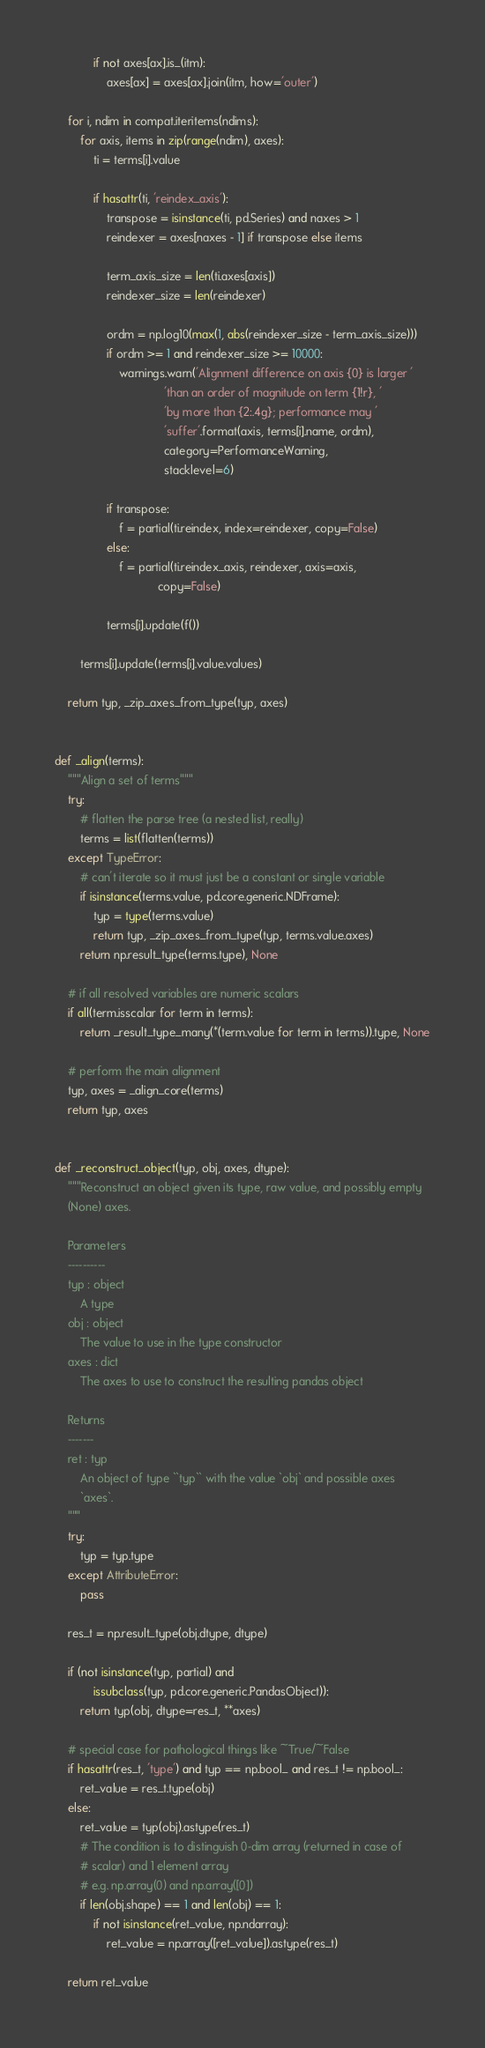<code> <loc_0><loc_0><loc_500><loc_500><_Python_>
            if not axes[ax].is_(itm):
                axes[ax] = axes[ax].join(itm, how='outer')

    for i, ndim in compat.iteritems(ndims):
        for axis, items in zip(range(ndim), axes):
            ti = terms[i].value

            if hasattr(ti, 'reindex_axis'):
                transpose = isinstance(ti, pd.Series) and naxes > 1
                reindexer = axes[naxes - 1] if transpose else items

                term_axis_size = len(ti.axes[axis])
                reindexer_size = len(reindexer)

                ordm = np.log10(max(1, abs(reindexer_size - term_axis_size)))
                if ordm >= 1 and reindexer_size >= 10000:
                    warnings.warn('Alignment difference on axis {0} is larger '
                                  'than an order of magnitude on term {1!r}, '
                                  'by more than {2:.4g}; performance may '
                                  'suffer'.format(axis, terms[i].name, ordm),
                                  category=PerformanceWarning,
                                  stacklevel=6)

                if transpose:
                    f = partial(ti.reindex, index=reindexer, copy=False)
                else:
                    f = partial(ti.reindex_axis, reindexer, axis=axis,
                                copy=False)

                terms[i].update(f())

        terms[i].update(terms[i].value.values)

    return typ, _zip_axes_from_type(typ, axes)


def _align(terms):
    """Align a set of terms"""
    try:
        # flatten the parse tree (a nested list, really)
        terms = list(flatten(terms))
    except TypeError:
        # can't iterate so it must just be a constant or single variable
        if isinstance(terms.value, pd.core.generic.NDFrame):
            typ = type(terms.value)
            return typ, _zip_axes_from_type(typ, terms.value.axes)
        return np.result_type(terms.type), None

    # if all resolved variables are numeric scalars
    if all(term.isscalar for term in terms):
        return _result_type_many(*(term.value for term in terms)).type, None

    # perform the main alignment
    typ, axes = _align_core(terms)
    return typ, axes


def _reconstruct_object(typ, obj, axes, dtype):
    """Reconstruct an object given its type, raw value, and possibly empty
    (None) axes.

    Parameters
    ----------
    typ : object
        A type
    obj : object
        The value to use in the type constructor
    axes : dict
        The axes to use to construct the resulting pandas object

    Returns
    -------
    ret : typ
        An object of type ``typ`` with the value `obj` and possible axes
        `axes`.
    """
    try:
        typ = typ.type
    except AttributeError:
        pass

    res_t = np.result_type(obj.dtype, dtype)

    if (not isinstance(typ, partial) and
            issubclass(typ, pd.core.generic.PandasObject)):
        return typ(obj, dtype=res_t, **axes)

    # special case for pathological things like ~True/~False
    if hasattr(res_t, 'type') and typ == np.bool_ and res_t != np.bool_:
        ret_value = res_t.type(obj)
    else:
        ret_value = typ(obj).astype(res_t)
        # The condition is to distinguish 0-dim array (returned in case of
        # scalar) and 1 element array
        # e.g. np.array(0) and np.array([0])
        if len(obj.shape) == 1 and len(obj) == 1:
            if not isinstance(ret_value, np.ndarray):
                ret_value = np.array([ret_value]).astype(res_t)

    return ret_value
</code> 